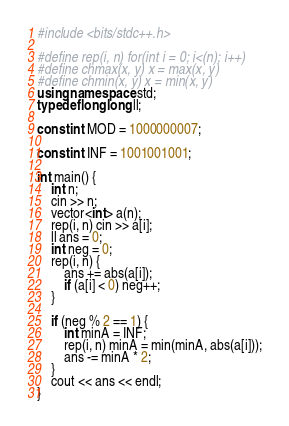Convert code to text. <code><loc_0><loc_0><loc_500><loc_500><_C++_>#include <bits/stdc++.h>

#define rep(i, n) for(int i = 0; i<(n); i++)
#define chmax(x, y) x = max(x, y)
#define chmin(x, y) x = min(x, y)
using namespace std;
typedef long long ll;

const int MOD = 1000000007;

const int INF = 1001001001;

int main() {
    int n;
    cin >> n;
    vector<int> a(n);
    rep(i, n) cin >> a[i];
    ll ans = 0;
    int neg = 0;
    rep(i, n) {
        ans += abs(a[i]);
        if (a[i] < 0) neg++;
    }

    if (neg % 2 == 1) {
        int minA = INF;
        rep(i, n) minA = min(minA, abs(a[i]));
        ans -= minA * 2;
    }
    cout << ans << endl;
}</code> 